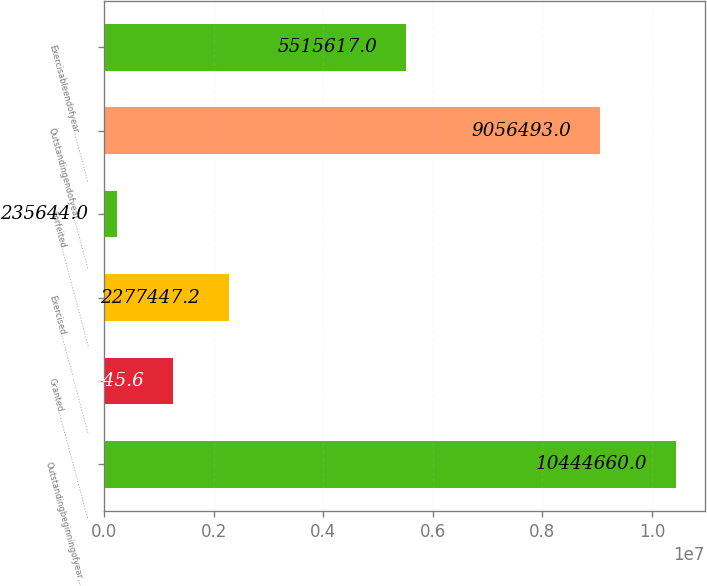Convert chart to OTSL. <chart><loc_0><loc_0><loc_500><loc_500><bar_chart><fcel>Outstandingbeginningofyear…………<fcel>Granted…………………………………<fcel>Exercised………………………………<fcel>Forfeited………………………………<fcel>Outstandingendofyear………………<fcel>Exercisableendofyear………………<nl><fcel>1.04447e+07<fcel>1.25655e+06<fcel>2.27745e+06<fcel>235644<fcel>9.05649e+06<fcel>5.51562e+06<nl></chart> 